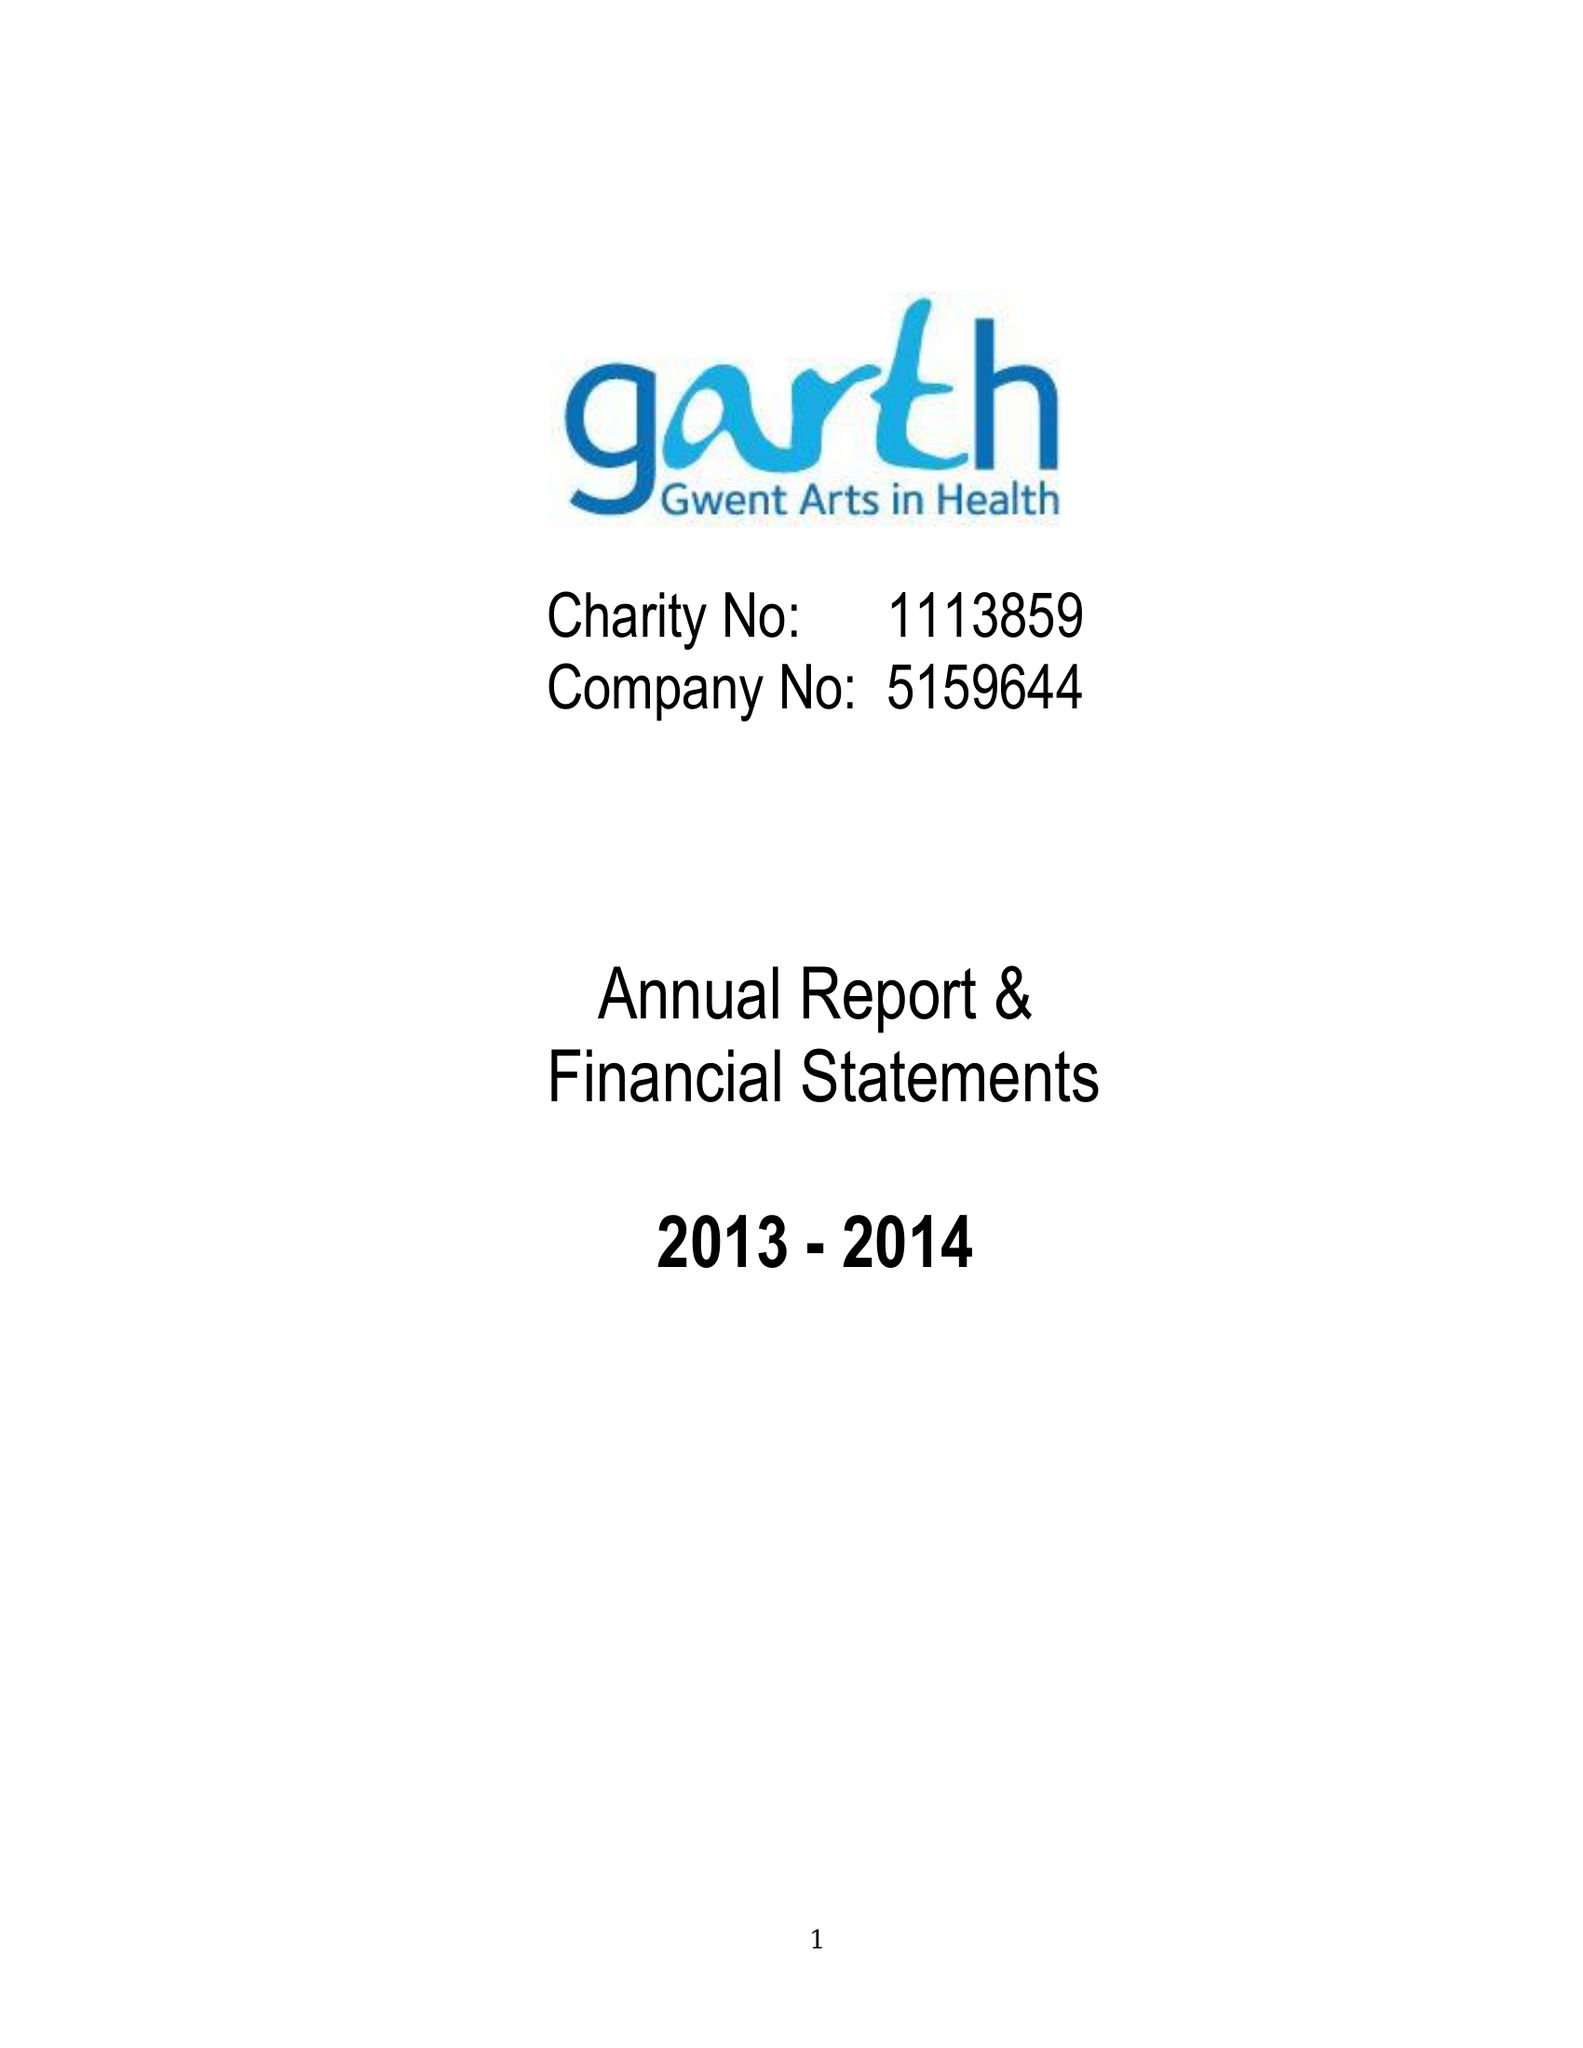What is the value for the address__street_line?
Answer the question using a single word or phrase. CARDIFF ROAD 